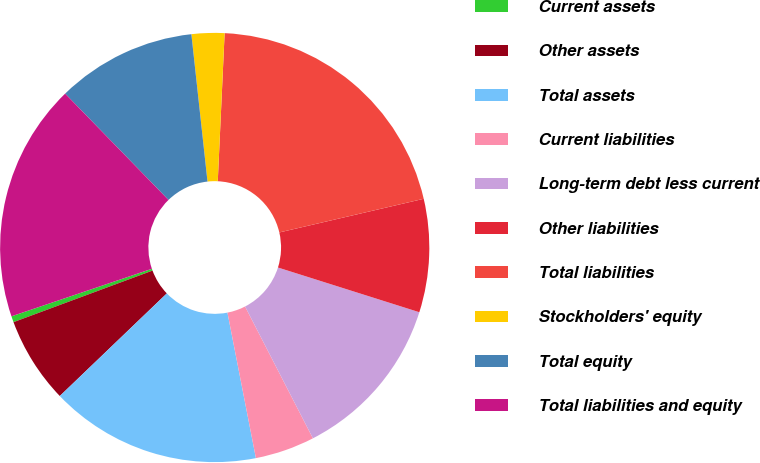Convert chart to OTSL. <chart><loc_0><loc_0><loc_500><loc_500><pie_chart><fcel>Current assets<fcel>Other assets<fcel>Total assets<fcel>Current liabilities<fcel>Long-term debt less current<fcel>Other liabilities<fcel>Total liabilities<fcel>Stockholders' equity<fcel>Total equity<fcel>Total liabilities and equity<nl><fcel>0.46%<fcel>6.51%<fcel>15.91%<fcel>4.49%<fcel>12.56%<fcel>8.52%<fcel>20.62%<fcel>2.47%<fcel>10.54%<fcel>17.92%<nl></chart> 